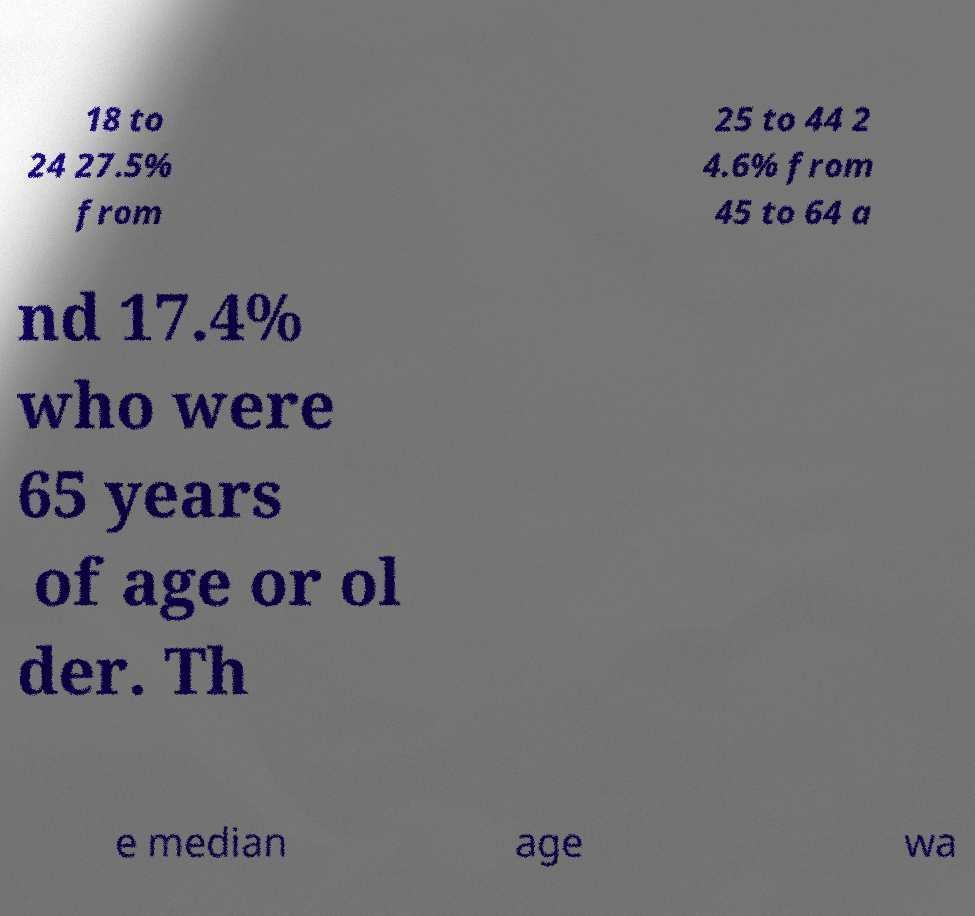Can you accurately transcribe the text from the provided image for me? 18 to 24 27.5% from 25 to 44 2 4.6% from 45 to 64 a nd 17.4% who were 65 years of age or ol der. Th e median age wa 